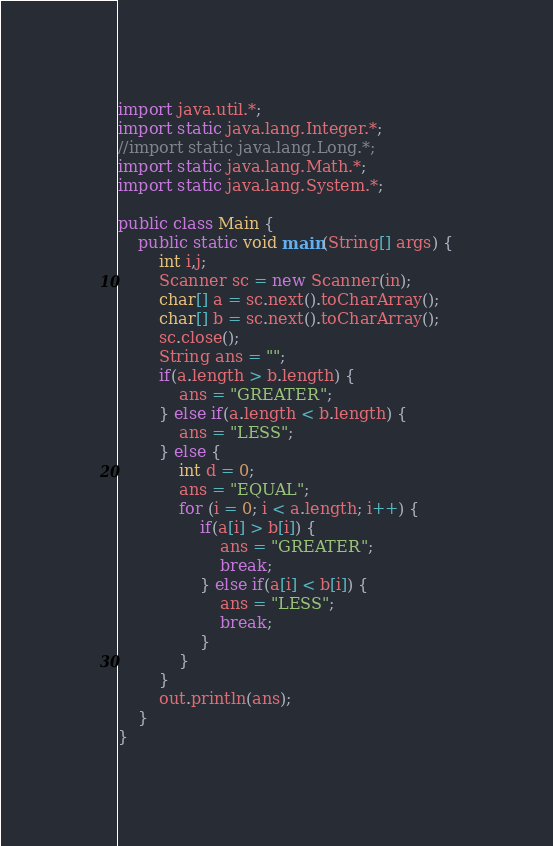<code> <loc_0><loc_0><loc_500><loc_500><_Java_>import java.util.*;
import static java.lang.Integer.*;
//import static java.lang.Long.*;
import static java.lang.Math.*;
import static java.lang.System.*;

public class Main {
	public static void main(String[] args) {
		int i,j;
		Scanner sc = new Scanner(in);
		char[] a = sc.next().toCharArray();
		char[] b = sc.next().toCharArray();
		sc.close();
		String ans = "";
		if(a.length > b.length) {
			ans = "GREATER";
		} else if(a.length < b.length) {
			ans = "LESS";
		} else {
			int d = 0;
			ans = "EQUAL";
			for (i = 0; i < a.length; i++) {
				if(a[i] > b[i]) {
					ans = "GREATER";
					break;
				} else if(a[i] < b[i]) {
					ans = "LESS";
					break;
				}
			}
		}
		out.println(ans);
	}
}
</code> 